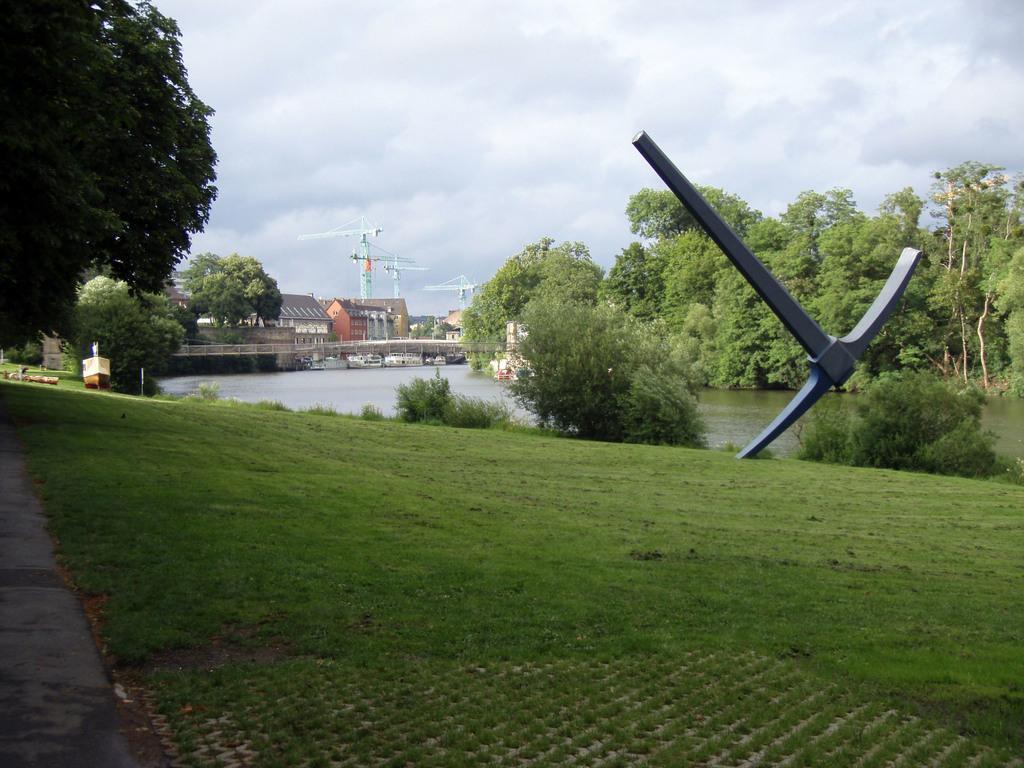Could you give a brief overview of what you see in this image? In this image we can see the houses, bridge, trees, cranes, plants and also the grass. We can also see the path, water, a structure and also the sky with the clouds. 